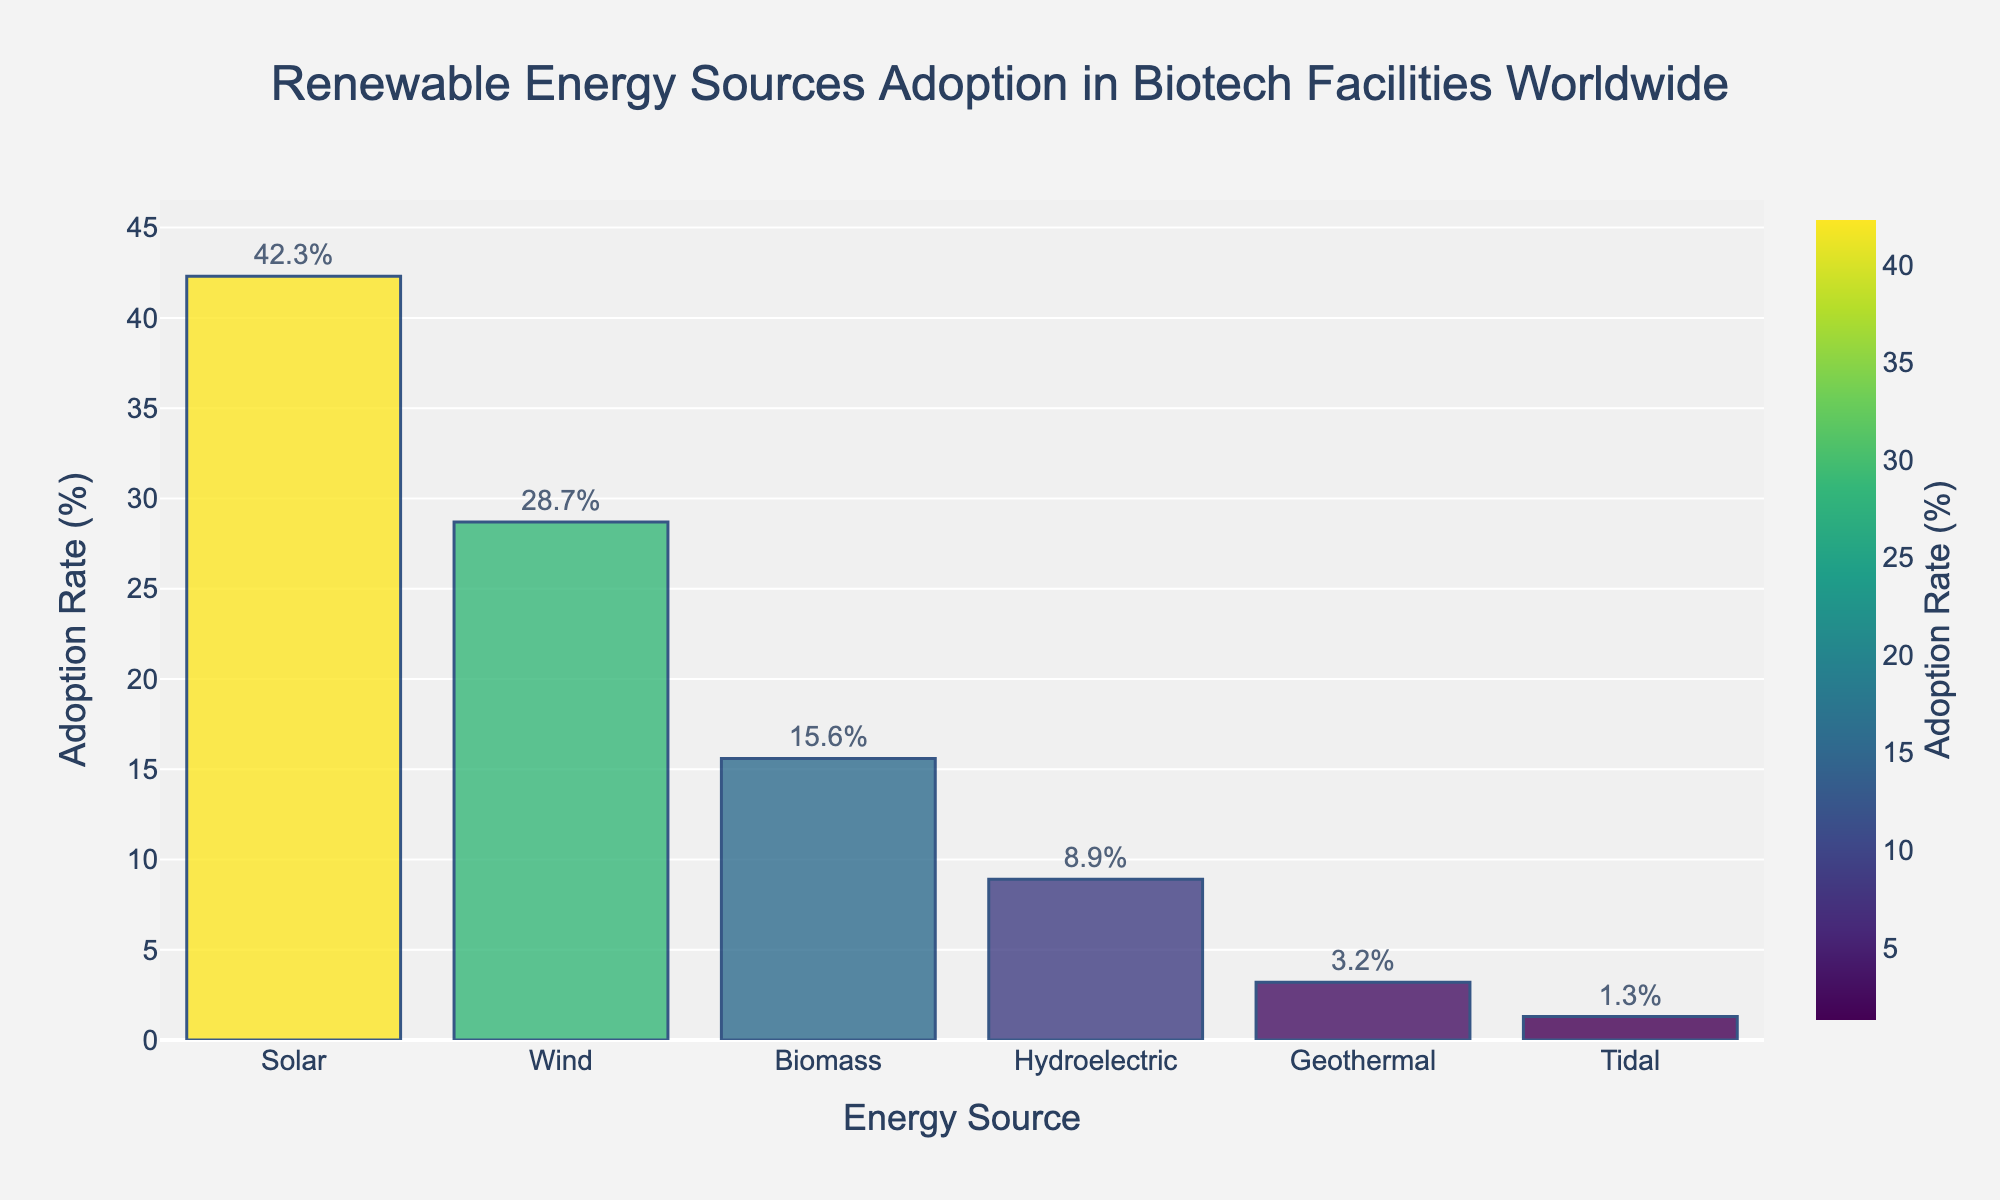Which renewable energy source has the highest adoption rate in biotech facilities worldwide? Observing the heights of the bars, the one representing Solar energy is the tallest, indicating the highest adoption rate.
Answer: Solar How much more popular is Wind energy compared to Biomass energy? The adoption rate of Wind energy is 28.7%, and Biomass energy is 15.6%. Subtracting Biomass's rate from Wind's rate: 28.7% - 15.6% = 13.1%.
Answer: 13.1% Which energy source has the lowest adoption rate, and what is the percentage? The shortest bar represents Tidal energy, indicating the lowest adoption rate at 1.3%.
Answer: Tidal, 1.3% What is the combined adoption rate of Solar, Wind, and Biomass energy sources? Adding the percentages of Solar (42.3%), Wind (28.7%), and Biomass (15.6%): 42.3% + 28.7% + 15.6% = 86.6%.
Answer: 86.6% Is the adoption rate of Geothermal energy higher or lower than 5%? From the bar chart, the Geothermal energy bar reaches 3.2%, which is lower than 5%.
Answer: Lower How does the adoption rate of Hydroelectric energy compare to Geothermal and Tidal energy combined? The percentage for Hydroelectric is 8.9%. Adding Geothermal (3.2%) and Tidal (1.3%): 3.2% + 1.3% = 4.5%. Hydroelectric (8.9%) is higher.
Answer: Higher Which two energy sources combined have an adoption rate closest to 50%? Checking combinations: Solar (42.3%) + Biomass (15.6%) = 57.9%; Wind (28.7%) + Biomass (15.6%) = 44.3%; Solar (42.3%) + Geothermal (3.2%) = 45.5%. The closest is Wind and Biomass at 44.3%.
Answer: Wind and Biomass What is the difference in adoption rate between the most and least adopted energy sources? The most adopted is Solar (42.3%), and the least is Tidal (1.3%). Subtracting Tidal from Solar: 42.3% - 1.3% = 41.0%.
Answer: 41.0% What is the average adoption rate of all renewable energy sources presented? Adding all percentages: 42.3% + 28.7% + 15.6% + 8.9% + 3.2% + 1.3% = 100%. Dividing by the number of sources (6): 100% / 6 ≈ 16.67%.
Answer: ~16.67% How much does Biomass energy's adoption rate need to increase to reach 20%? Biomass is currently at 15.6%. To reach 20%: 20% - 15.6% = 4.4%.
Answer: 4.4% 